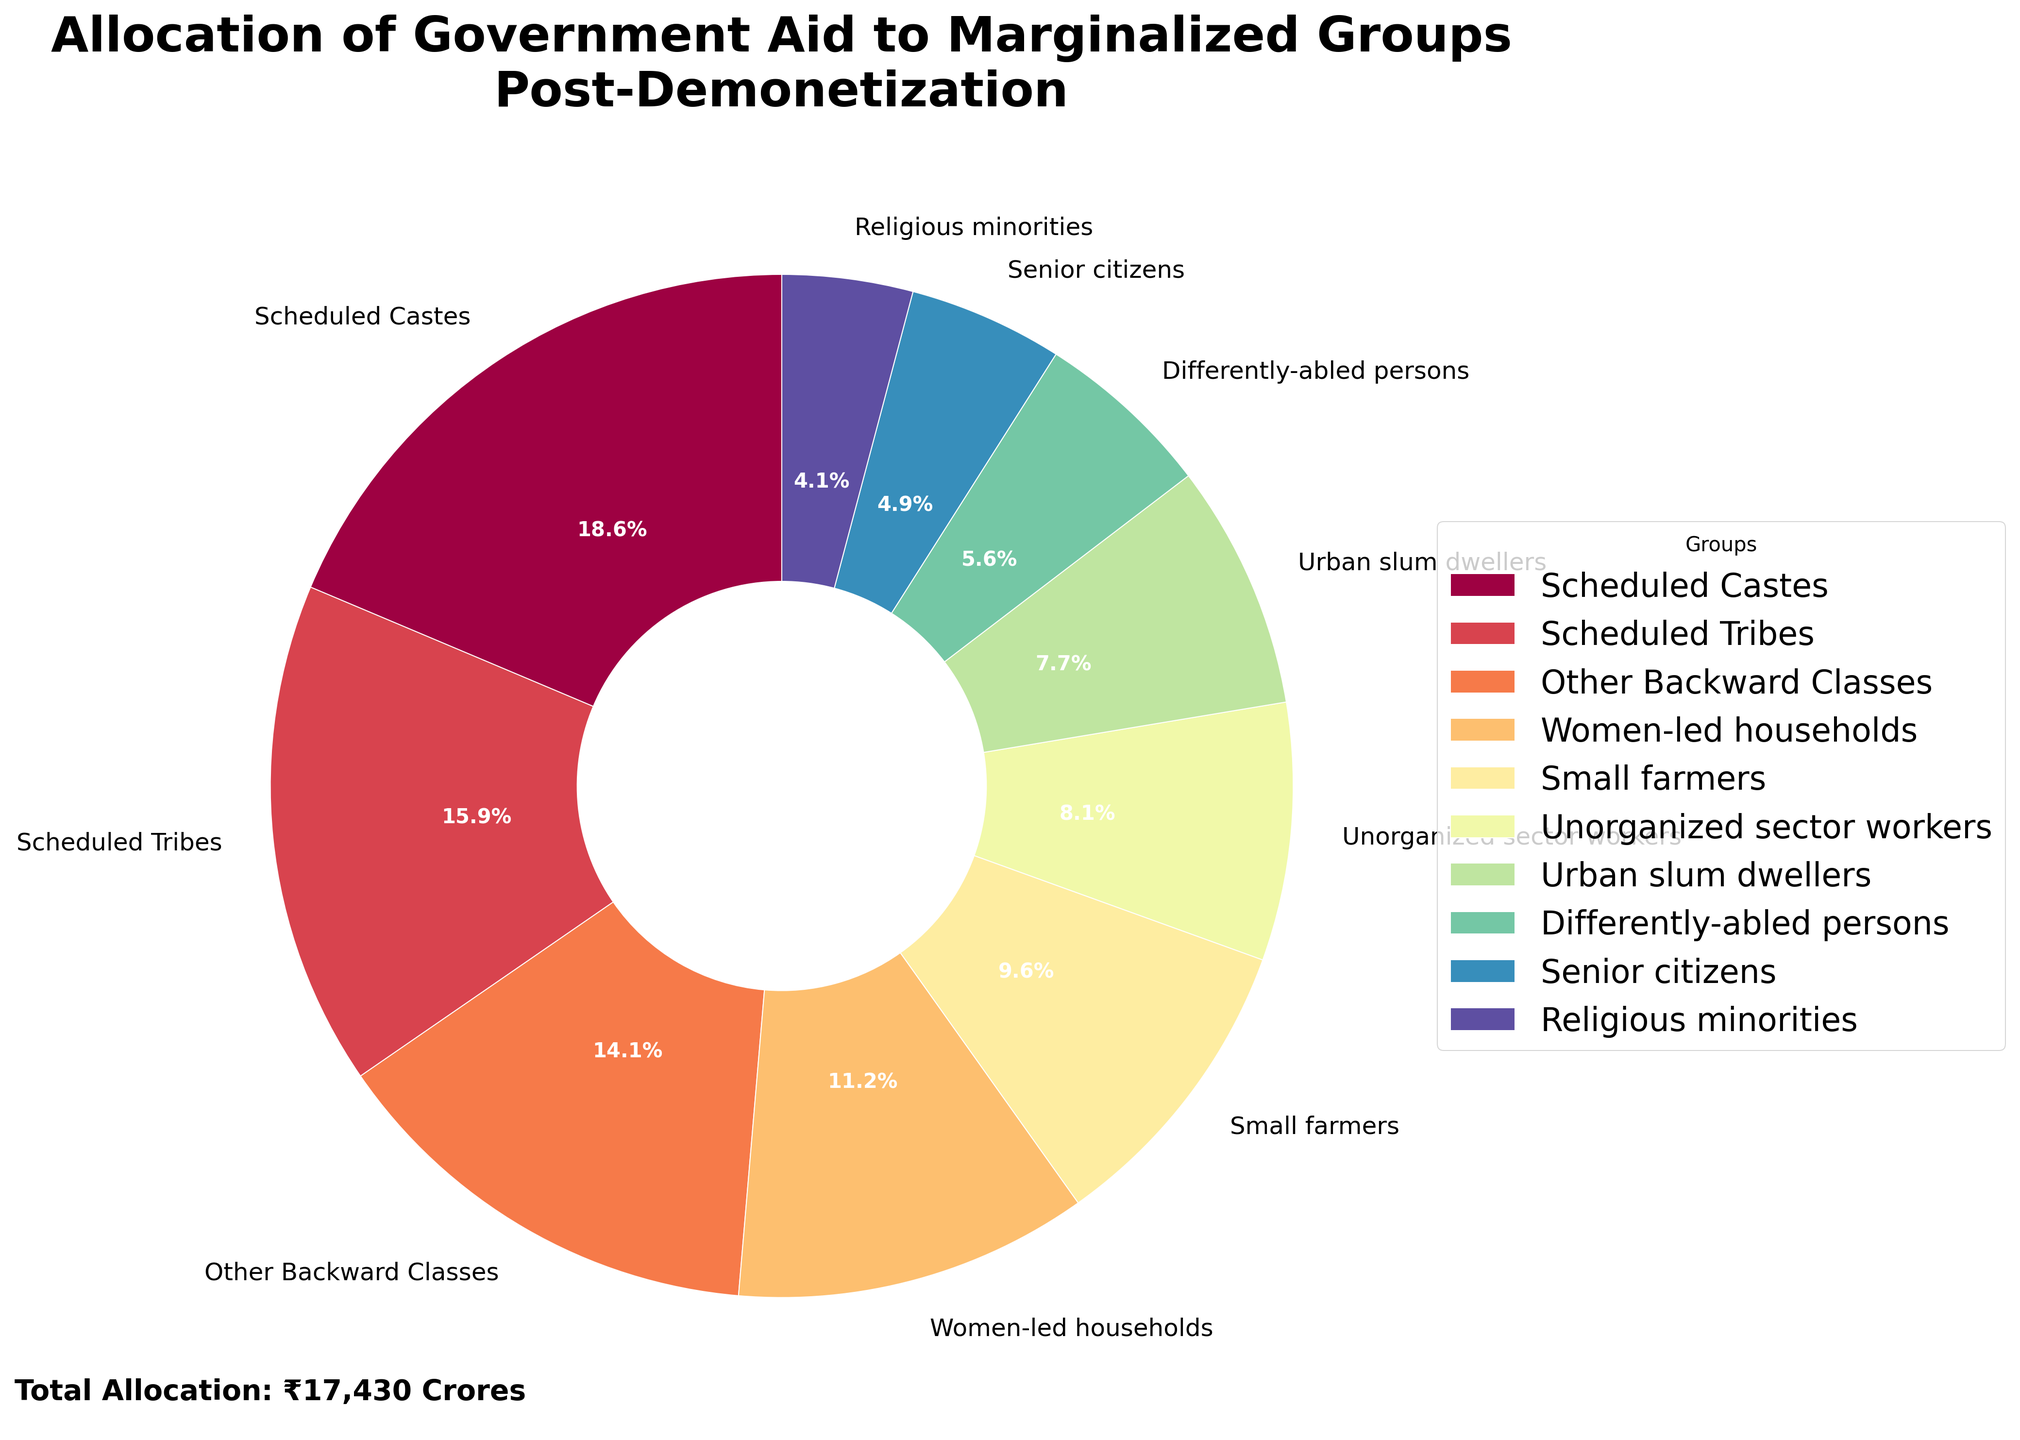Which group received the most government aid post-demonetization? By looking at the largest slice of the pie chart, we can see that the Scheduled Castes group has the highest percentage and thus received the most government aid.
Answer: Scheduled Castes What is the total percentage of aid allocated to Scheduled Castes and Scheduled Tribes? The percentage of aid allocated to Scheduled Castes is 25.0% and to Scheduled Tribes is 21.4%. Adding these together gives us 25.0% + 21.4% = 46.4%.
Answer: 46.4% Which group received less aid: Urban slum dwellers or Differently-abled persons? By comparing the sizes of the slices in the pie chart, it is visible that the slice for Differently-abled persons is smaller than that for Urban slum dwellers.
Answer: Differently-abled persons What is the difference in aid allocation between Scheduled Castes and Senior citizens? Scheduled Castes received 3250 crores of aid and Senior citizens received 850 crores. The difference is calculated as 3250 - 850 = 2400 crores.
Answer: 2400 crores How many groups received less than 10% of the total aid each? From the pie chart, we can see that Women-led households, Small farmers, Unorganized sector workers, Urban slum dwellers, Differently-abled persons, Senior citizens, and Religious minorities each received less than 10% of the total aid. Counting these groups gives 7 groups.
Answer: 7 Which group has a visually similar-sized slice as Religious minorities? By examining the size of the slices in the pie chart, the Senior citizens group has a visually similar-sized slice to the Religious minorities group.
Answer: Senior citizens What is the cumulative aid allocation for Women-led households and Small farmers? Women-led households received 1950 crores and Small farmers received 1680 crores. The sum is 1950 + 1680 = 3630 crores.
Answer: 3630 crores What percentage of the total aid was allocated to groups receiving less than 2000 crores each? Adding the aid for Women-led households (1950 crores), Small farmers (1680 crores), Unorganized sector workers (1420 crores), Urban slum dwellers (1350 crores), Differently-abled persons (980 crores), Senior citizens (850 crores), and Religious minorities (720 crores) and calculating the percentage of the total sum (16980 crores) shows: (1950+1680+1420+1350+980+850+720) / 16980 * 100% = 9090 / 16980 = 0.535, which is 53.5%.
Answer: 53.5% 